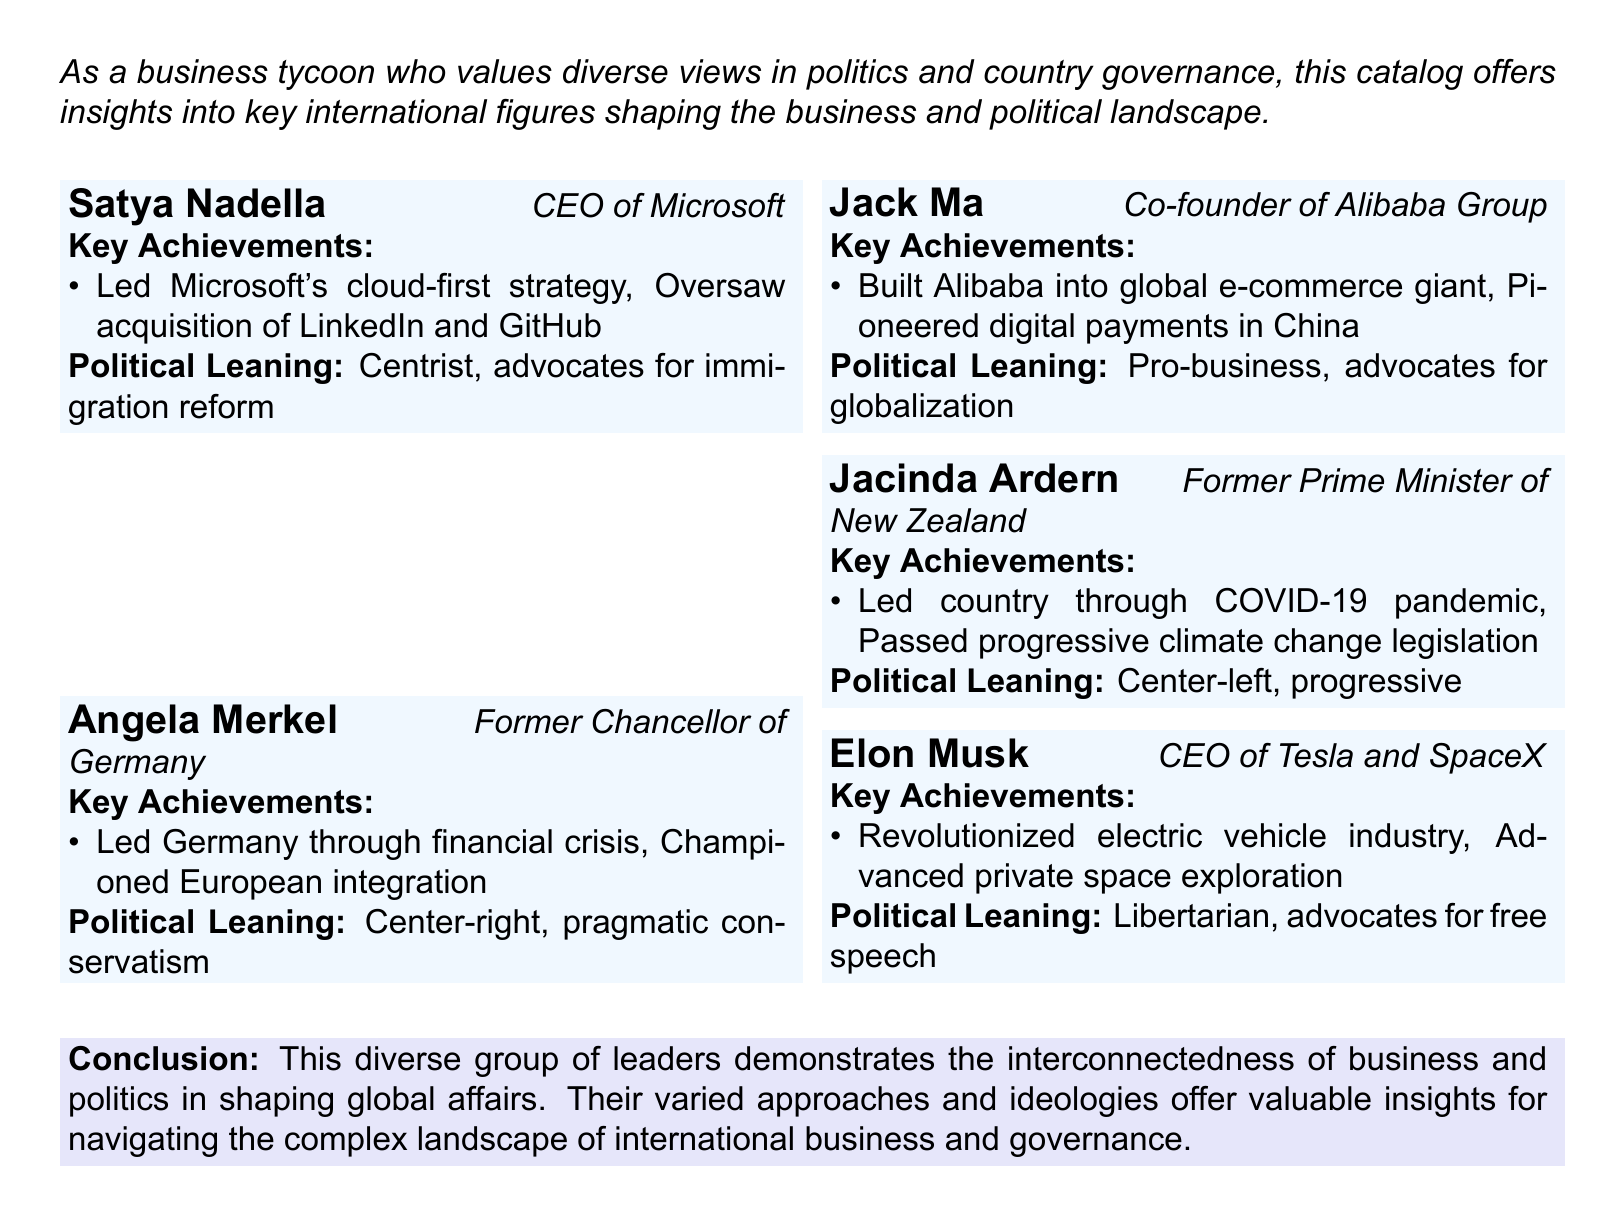What is Satya Nadella's position? Satya Nadella is identified in the document as the CEO of Microsoft.
Answer: CEO of Microsoft Who is the co-founder of Alibaba Group? The document states that Jack Ma is the co-founder of Alibaba Group.
Answer: Jack Ma What significant crisis did Angela Merkel lead Germany through? The document mentions that Angela Merkel led Germany through the financial crisis.
Answer: Financial crisis Which politician is associated with progressive climate change legislation? According to the document, Jacinda Ardern passed progressive climate change legislation.
Answer: Jacinda Ardern What political leaning is associated with Elon Musk? The document indicates that Elon Musk is categorized as a libertarian.
Answer: Libertarian How many international figures are listed in the catalog? The document provides five entries which denote the number of international figures listed.
Answer: Five What major strategy did Satya Nadella lead at Microsoft? The document notes that Satya Nadella led Microsoft's cloud-first strategy.
Answer: Cloud-first strategy Which leader is described as advocating for globalization? Jack Ma is identified in the document as advocating for globalization.
Answer: Jack Ma What background is highlighted for Jacinda Ardern in the document? The document provides the background of Jacinda Ardern leading the country through the COVID-19 pandemic.
Answer: COVID-19 pandemic 